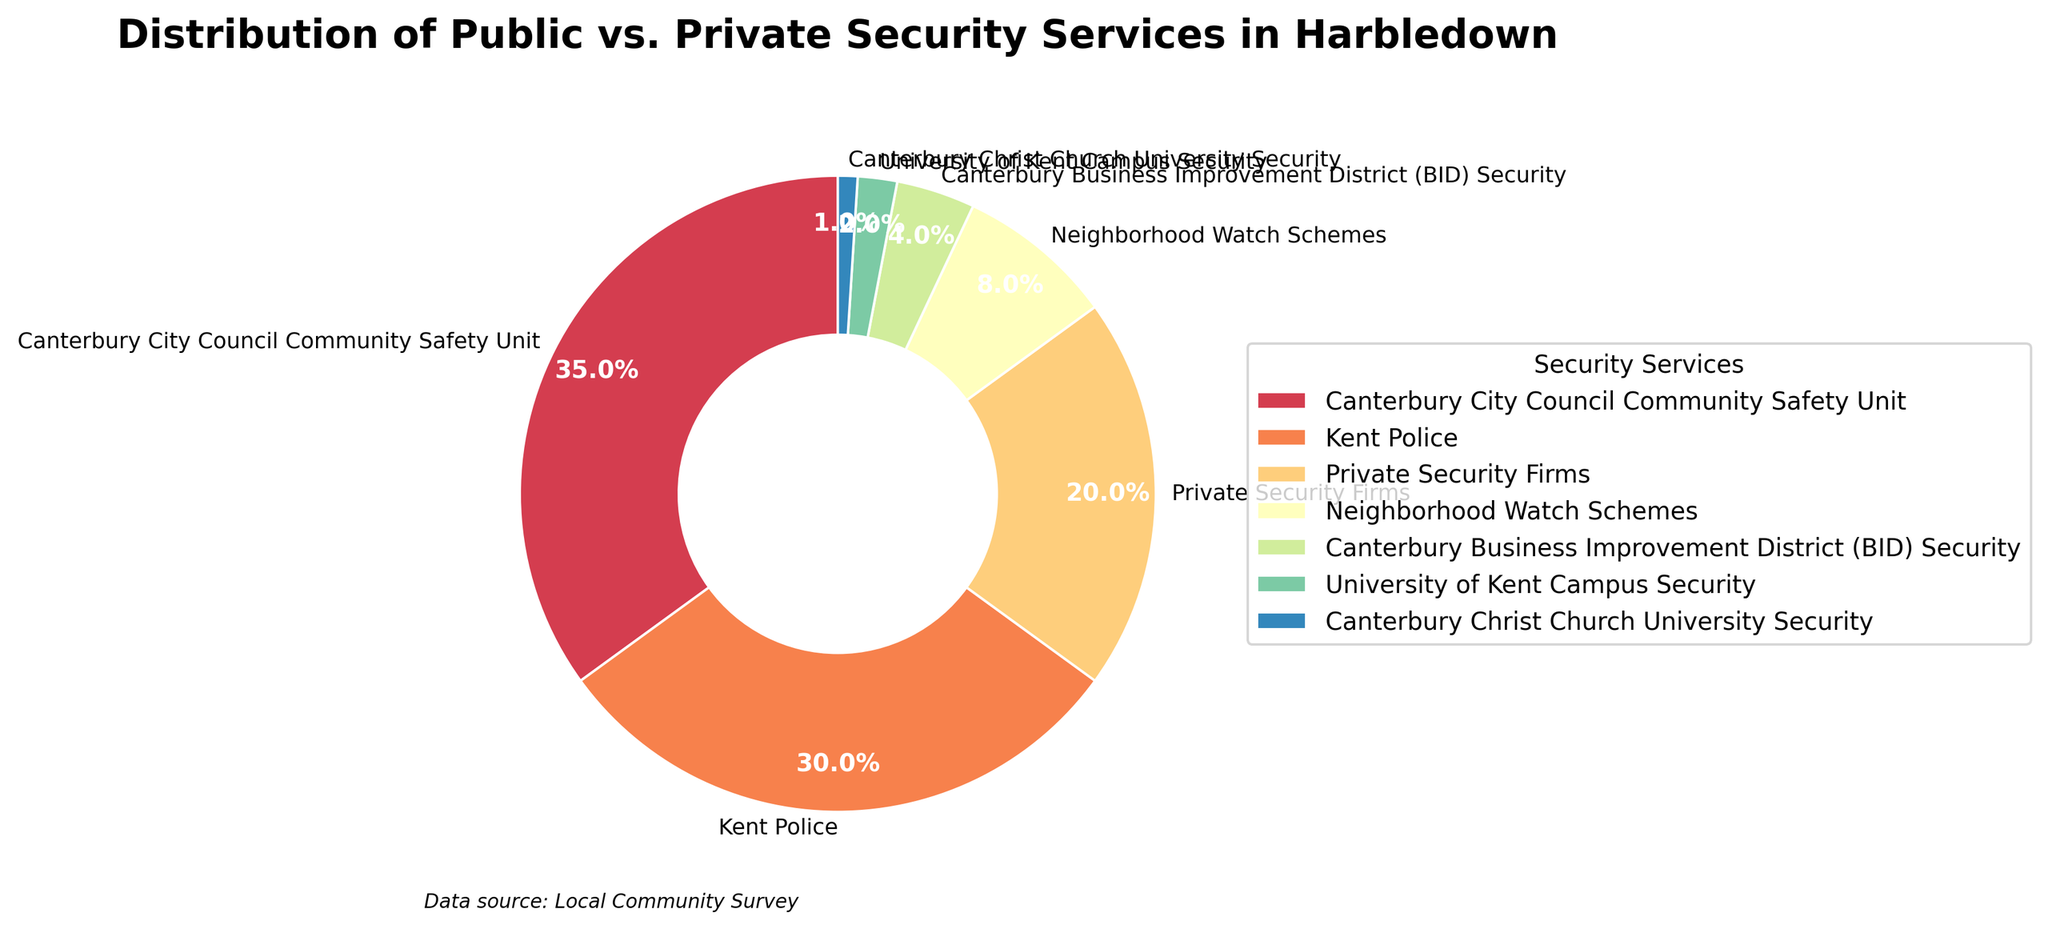Which security service provides the largest percentage of security in Harbledown? From the pie chart, we can see that the largest segment belongs to the Canterbury City Council Community Safety Unit. They provide 35% of the total security services.
Answer: Canterbury City Council Community Safety Unit What is the total percentage of security services provided by public entities (Canterbury City Council Community Safety Unit, Kent Police, Neighborhood Watch Schemes)? Sum the percentages of the Canterbury City Council Community Safety Unit (35%), Kent Police (30%), and Neighborhood Watch Schemes (8%). This equals 35 + 30 + 8 = 73%.
Answer: 73% How does the percentage of security services provided by private entities (Private Security Firms, Canterbury Business Improvement District (BID) Security) compare to those by public entities? Private entities include Private Security Firms (20%) and Canterbury BID Security (4%). Summing these up gives 20 + 4 = 24%. Public entities provide 73%. Therefore, public entities provide a much larger percentage of security services (73% compared to 24%).
Answer: Public entities > Private entities Which security service provides a smaller percentage of security services: University of Kent Campus Security or Canterbury Christ Church University Security? From the pie chart, University of Kent Campus Security provides 2%, and Canterbury Christ Church University Security provides 1%. Therefore, Canterbury Christ Church University Security provides a smaller percentage.
Answer: Canterbury Christ Church University Security What percentage of security services is provided by educational institutions (University of Kent Campus Security + Canterbury Christ Church University Security)? Sum the percentages for University of Kent Campus Security (2%) and Canterbury Christ Church University Security (1%). This equals 2 + 1 = 3%.
Answer: 3% Compare the combined percentage of security services provided by private entities to those provided by the Kent Police. Combined private entities (Private Security Firms, Canterbury BID Security) provide 24%. Kent Police provide 30% alone. Therefore, the Kent Police provide a higher percentage than all private entities combined.
Answer: Kent Police > Private entities combined What is the difference in percentage between Canterbury City Council Community Safety Unit and Kent Police? Subtract the percentage of Kent Police (30%) from the Canterbury City Council Community Safety Unit (35%). This gives 35 - 30 = 5%.
Answer: 5% How do the colors used in the pie chart help differentiate between the different security services? The pie chart uses different colors for each segment to visually separate different security services. This makes it easier to identify and compare the proportions for each service at a glance.
Answer: Visually separate segments Is the total percentage of security services provided by non-educational institutions greater or less than 95%? Non-educational institutions include all services except University of Kent Campus Security (2%) and Canterbury Christ Church University Security (1%). The total for non-educational institutions is 100% - (2% + 1%) = 97%, which is greater than 95%.
Answer: Greater than 95% 